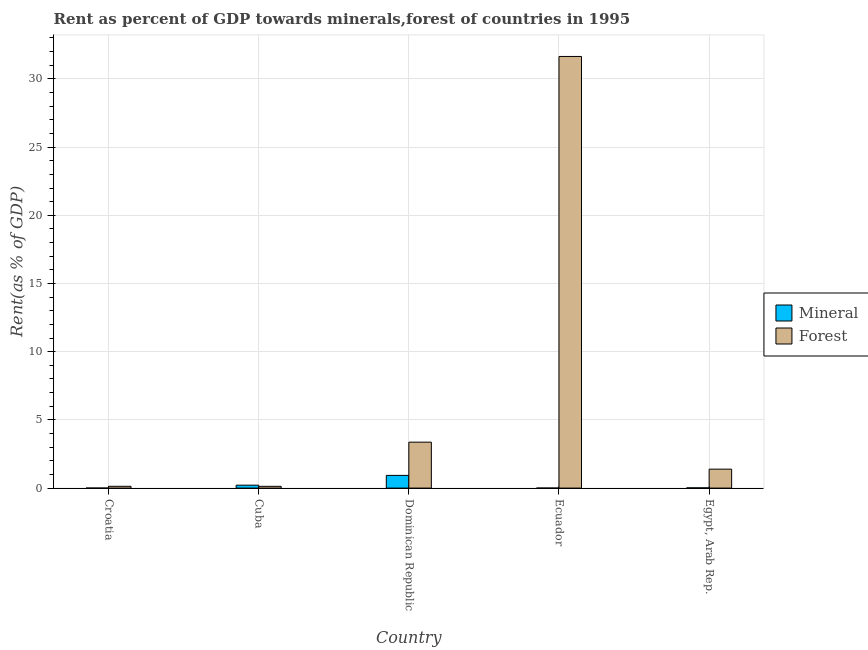How many groups of bars are there?
Offer a very short reply. 5. What is the label of the 5th group of bars from the left?
Give a very brief answer. Egypt, Arab Rep. What is the forest rent in Ecuador?
Your answer should be compact. 31.64. Across all countries, what is the maximum forest rent?
Ensure brevity in your answer.  31.64. Across all countries, what is the minimum mineral rent?
Your response must be concise. 3.806095493169489e-5. In which country was the mineral rent maximum?
Keep it short and to the point. Dominican Republic. In which country was the forest rent minimum?
Give a very brief answer. Cuba. What is the total mineral rent in the graph?
Your answer should be compact. 1.16. What is the difference between the forest rent in Croatia and that in Ecuador?
Ensure brevity in your answer.  -31.51. What is the difference between the forest rent in Cuba and the mineral rent in Egypt, Arab Rep.?
Ensure brevity in your answer.  0.11. What is the average mineral rent per country?
Make the answer very short. 0.23. What is the difference between the mineral rent and forest rent in Cuba?
Your response must be concise. 0.09. In how many countries, is the forest rent greater than 16 %?
Ensure brevity in your answer.  1. What is the ratio of the mineral rent in Dominican Republic to that in Ecuador?
Offer a very short reply. 2243.94. What is the difference between the highest and the second highest mineral rent?
Provide a short and direct response. 0.72. What is the difference between the highest and the lowest mineral rent?
Provide a short and direct response. 0.93. What does the 1st bar from the left in Dominican Republic represents?
Offer a terse response. Mineral. What does the 2nd bar from the right in Croatia represents?
Your answer should be compact. Mineral. How many bars are there?
Your answer should be compact. 10. What is the difference between two consecutive major ticks on the Y-axis?
Offer a very short reply. 5. Are the values on the major ticks of Y-axis written in scientific E-notation?
Keep it short and to the point. No. Does the graph contain any zero values?
Provide a succinct answer. No. Where does the legend appear in the graph?
Ensure brevity in your answer.  Center right. How are the legend labels stacked?
Your response must be concise. Vertical. What is the title of the graph?
Offer a terse response. Rent as percent of GDP towards minerals,forest of countries in 1995. What is the label or title of the Y-axis?
Offer a terse response. Rent(as % of GDP). What is the Rent(as % of GDP) of Mineral in Croatia?
Provide a succinct answer. 3.806095493169489e-5. What is the Rent(as % of GDP) of Forest in Croatia?
Your answer should be very brief. 0.13. What is the Rent(as % of GDP) of Mineral in Cuba?
Provide a succinct answer. 0.21. What is the Rent(as % of GDP) of Forest in Cuba?
Offer a terse response. 0.13. What is the Rent(as % of GDP) in Mineral in Dominican Republic?
Give a very brief answer. 0.93. What is the Rent(as % of GDP) in Forest in Dominican Republic?
Ensure brevity in your answer.  3.37. What is the Rent(as % of GDP) of Mineral in Ecuador?
Give a very brief answer. 0. What is the Rent(as % of GDP) in Forest in Ecuador?
Ensure brevity in your answer.  31.64. What is the Rent(as % of GDP) of Mineral in Egypt, Arab Rep.?
Your response must be concise. 0.02. What is the Rent(as % of GDP) in Forest in Egypt, Arab Rep.?
Your answer should be very brief. 1.39. Across all countries, what is the maximum Rent(as % of GDP) in Mineral?
Provide a succinct answer. 0.93. Across all countries, what is the maximum Rent(as % of GDP) of Forest?
Your answer should be compact. 31.64. Across all countries, what is the minimum Rent(as % of GDP) of Mineral?
Provide a short and direct response. 3.806095493169489e-5. Across all countries, what is the minimum Rent(as % of GDP) of Forest?
Provide a short and direct response. 0.13. What is the total Rent(as % of GDP) of Mineral in the graph?
Make the answer very short. 1.16. What is the total Rent(as % of GDP) in Forest in the graph?
Ensure brevity in your answer.  36.66. What is the difference between the Rent(as % of GDP) in Mineral in Croatia and that in Cuba?
Your response must be concise. -0.21. What is the difference between the Rent(as % of GDP) of Forest in Croatia and that in Cuba?
Give a very brief answer. 0. What is the difference between the Rent(as % of GDP) of Mineral in Croatia and that in Dominican Republic?
Offer a very short reply. -0.93. What is the difference between the Rent(as % of GDP) of Forest in Croatia and that in Dominican Republic?
Your answer should be very brief. -3.24. What is the difference between the Rent(as % of GDP) of Mineral in Croatia and that in Ecuador?
Provide a succinct answer. -0. What is the difference between the Rent(as % of GDP) in Forest in Croatia and that in Ecuador?
Keep it short and to the point. -31.51. What is the difference between the Rent(as % of GDP) in Mineral in Croatia and that in Egypt, Arab Rep.?
Offer a terse response. -0.02. What is the difference between the Rent(as % of GDP) in Forest in Croatia and that in Egypt, Arab Rep.?
Provide a short and direct response. -1.26. What is the difference between the Rent(as % of GDP) of Mineral in Cuba and that in Dominican Republic?
Provide a short and direct response. -0.72. What is the difference between the Rent(as % of GDP) of Forest in Cuba and that in Dominican Republic?
Give a very brief answer. -3.24. What is the difference between the Rent(as % of GDP) of Mineral in Cuba and that in Ecuador?
Make the answer very short. 0.21. What is the difference between the Rent(as % of GDP) of Forest in Cuba and that in Ecuador?
Your response must be concise. -31.52. What is the difference between the Rent(as % of GDP) of Mineral in Cuba and that in Egypt, Arab Rep.?
Offer a very short reply. 0.2. What is the difference between the Rent(as % of GDP) of Forest in Cuba and that in Egypt, Arab Rep.?
Make the answer very short. -1.26. What is the difference between the Rent(as % of GDP) in Mineral in Dominican Republic and that in Ecuador?
Ensure brevity in your answer.  0.93. What is the difference between the Rent(as % of GDP) in Forest in Dominican Republic and that in Ecuador?
Give a very brief answer. -28.28. What is the difference between the Rent(as % of GDP) of Mineral in Dominican Republic and that in Egypt, Arab Rep.?
Give a very brief answer. 0.92. What is the difference between the Rent(as % of GDP) in Forest in Dominican Republic and that in Egypt, Arab Rep.?
Provide a succinct answer. 1.98. What is the difference between the Rent(as % of GDP) of Mineral in Ecuador and that in Egypt, Arab Rep.?
Offer a very short reply. -0.02. What is the difference between the Rent(as % of GDP) in Forest in Ecuador and that in Egypt, Arab Rep.?
Your answer should be very brief. 30.26. What is the difference between the Rent(as % of GDP) in Mineral in Croatia and the Rent(as % of GDP) in Forest in Cuba?
Your response must be concise. -0.13. What is the difference between the Rent(as % of GDP) in Mineral in Croatia and the Rent(as % of GDP) in Forest in Dominican Republic?
Keep it short and to the point. -3.37. What is the difference between the Rent(as % of GDP) of Mineral in Croatia and the Rent(as % of GDP) of Forest in Ecuador?
Provide a succinct answer. -31.64. What is the difference between the Rent(as % of GDP) in Mineral in Croatia and the Rent(as % of GDP) in Forest in Egypt, Arab Rep.?
Your answer should be very brief. -1.39. What is the difference between the Rent(as % of GDP) in Mineral in Cuba and the Rent(as % of GDP) in Forest in Dominican Republic?
Offer a very short reply. -3.15. What is the difference between the Rent(as % of GDP) in Mineral in Cuba and the Rent(as % of GDP) in Forest in Ecuador?
Provide a short and direct response. -31.43. What is the difference between the Rent(as % of GDP) in Mineral in Cuba and the Rent(as % of GDP) in Forest in Egypt, Arab Rep.?
Your answer should be very brief. -1.17. What is the difference between the Rent(as % of GDP) of Mineral in Dominican Republic and the Rent(as % of GDP) of Forest in Ecuador?
Offer a very short reply. -30.71. What is the difference between the Rent(as % of GDP) in Mineral in Dominican Republic and the Rent(as % of GDP) in Forest in Egypt, Arab Rep.?
Your answer should be very brief. -0.46. What is the difference between the Rent(as % of GDP) of Mineral in Ecuador and the Rent(as % of GDP) of Forest in Egypt, Arab Rep.?
Offer a terse response. -1.39. What is the average Rent(as % of GDP) in Mineral per country?
Keep it short and to the point. 0.23. What is the average Rent(as % of GDP) in Forest per country?
Keep it short and to the point. 7.33. What is the difference between the Rent(as % of GDP) in Mineral and Rent(as % of GDP) in Forest in Croatia?
Provide a succinct answer. -0.13. What is the difference between the Rent(as % of GDP) in Mineral and Rent(as % of GDP) in Forest in Cuba?
Offer a terse response. 0.09. What is the difference between the Rent(as % of GDP) in Mineral and Rent(as % of GDP) in Forest in Dominican Republic?
Offer a terse response. -2.44. What is the difference between the Rent(as % of GDP) in Mineral and Rent(as % of GDP) in Forest in Ecuador?
Give a very brief answer. -31.64. What is the difference between the Rent(as % of GDP) of Mineral and Rent(as % of GDP) of Forest in Egypt, Arab Rep.?
Ensure brevity in your answer.  -1.37. What is the ratio of the Rent(as % of GDP) of Forest in Croatia to that in Cuba?
Your response must be concise. 1.02. What is the ratio of the Rent(as % of GDP) of Forest in Croatia to that in Dominican Republic?
Offer a very short reply. 0.04. What is the ratio of the Rent(as % of GDP) of Mineral in Croatia to that in Ecuador?
Your response must be concise. 0.09. What is the ratio of the Rent(as % of GDP) in Forest in Croatia to that in Ecuador?
Offer a terse response. 0. What is the ratio of the Rent(as % of GDP) in Mineral in Croatia to that in Egypt, Arab Rep.?
Your response must be concise. 0. What is the ratio of the Rent(as % of GDP) in Forest in Croatia to that in Egypt, Arab Rep.?
Offer a terse response. 0.09. What is the ratio of the Rent(as % of GDP) in Mineral in Cuba to that in Dominican Republic?
Ensure brevity in your answer.  0.23. What is the ratio of the Rent(as % of GDP) in Forest in Cuba to that in Dominican Republic?
Give a very brief answer. 0.04. What is the ratio of the Rent(as % of GDP) in Mineral in Cuba to that in Ecuador?
Offer a very short reply. 517.4. What is the ratio of the Rent(as % of GDP) of Forest in Cuba to that in Ecuador?
Your answer should be very brief. 0. What is the ratio of the Rent(as % of GDP) in Mineral in Cuba to that in Egypt, Arab Rep.?
Ensure brevity in your answer.  12.63. What is the ratio of the Rent(as % of GDP) of Forest in Cuba to that in Egypt, Arab Rep.?
Your answer should be very brief. 0.09. What is the ratio of the Rent(as % of GDP) of Mineral in Dominican Republic to that in Ecuador?
Offer a terse response. 2243.94. What is the ratio of the Rent(as % of GDP) of Forest in Dominican Republic to that in Ecuador?
Provide a succinct answer. 0.11. What is the ratio of the Rent(as % of GDP) of Mineral in Dominican Republic to that in Egypt, Arab Rep.?
Provide a succinct answer. 54.76. What is the ratio of the Rent(as % of GDP) of Forest in Dominican Republic to that in Egypt, Arab Rep.?
Your answer should be very brief. 2.42. What is the ratio of the Rent(as % of GDP) of Mineral in Ecuador to that in Egypt, Arab Rep.?
Give a very brief answer. 0.02. What is the ratio of the Rent(as % of GDP) of Forest in Ecuador to that in Egypt, Arab Rep.?
Provide a succinct answer. 22.78. What is the difference between the highest and the second highest Rent(as % of GDP) in Mineral?
Keep it short and to the point. 0.72. What is the difference between the highest and the second highest Rent(as % of GDP) in Forest?
Your response must be concise. 28.28. What is the difference between the highest and the lowest Rent(as % of GDP) of Mineral?
Give a very brief answer. 0.93. What is the difference between the highest and the lowest Rent(as % of GDP) in Forest?
Your response must be concise. 31.52. 